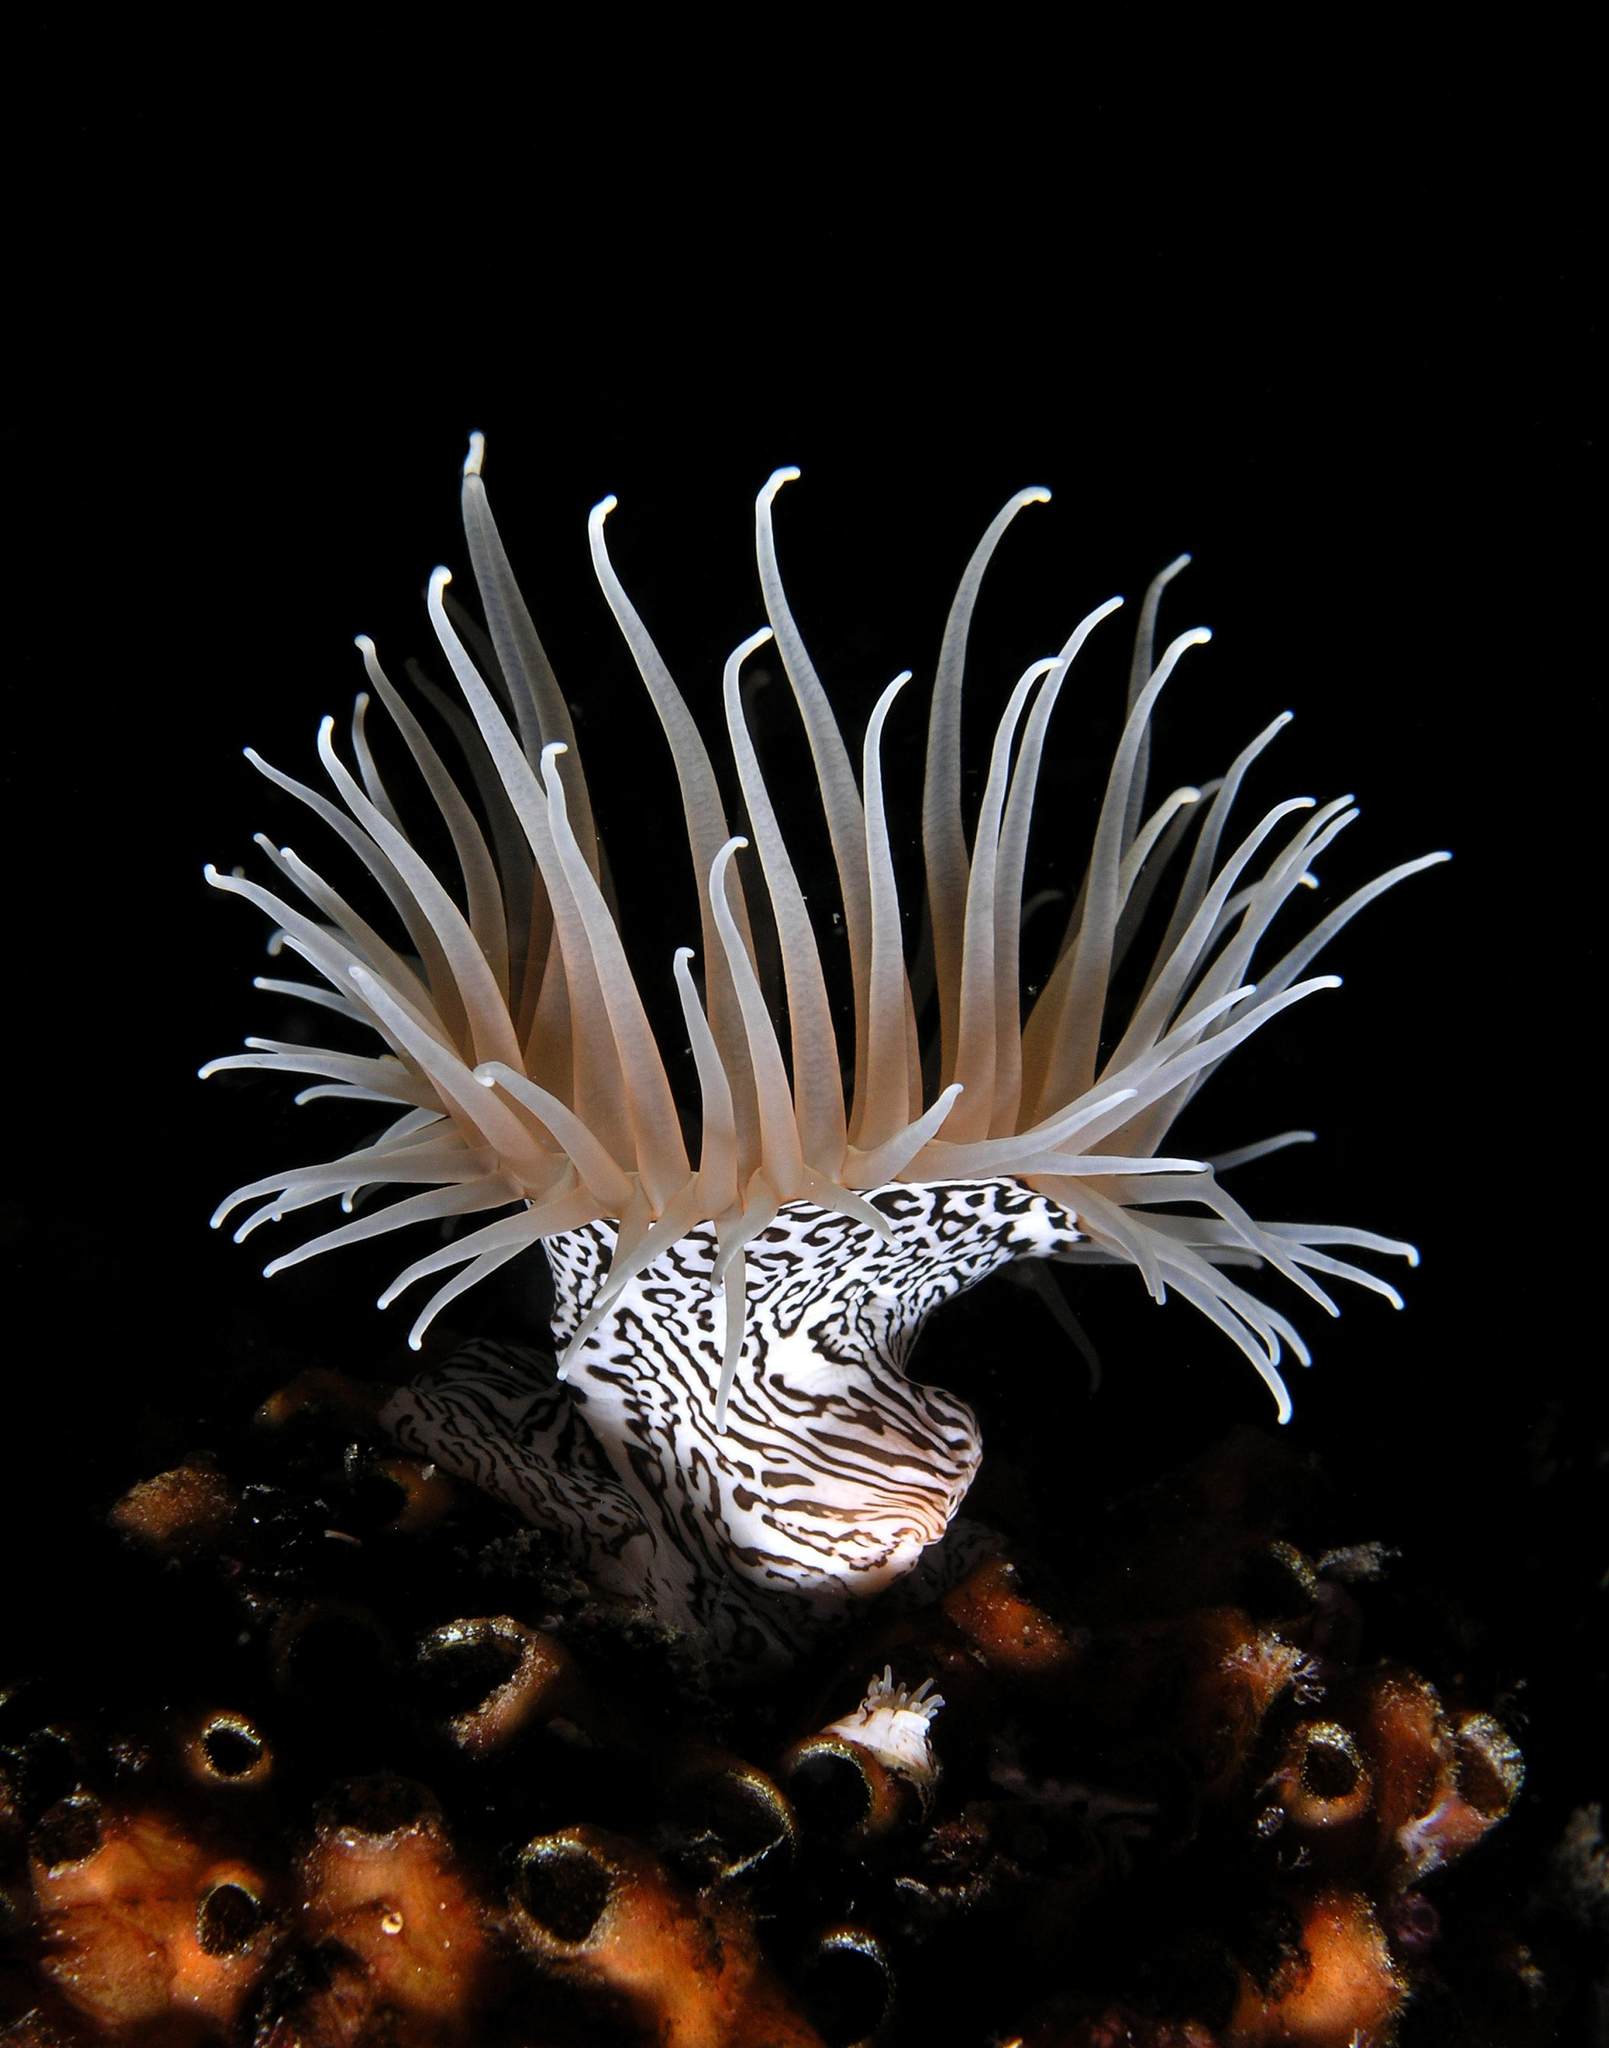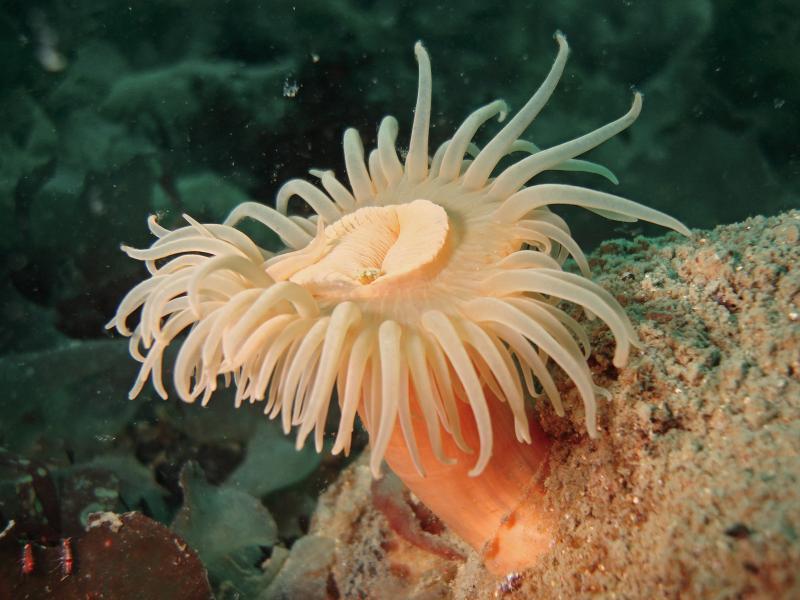The first image is the image on the left, the second image is the image on the right. Assess this claim about the two images: "There are exactly one sea anemone in each of the images.". Correct or not? Answer yes or no. Yes. The first image is the image on the left, the second image is the image on the right. Assess this claim about the two images: "One image features a peach-colored anemone with a thick stalk, and the other shows anemone with a black-and-white zebra-look pattern on the stalk.". Correct or not? Answer yes or no. Yes. 